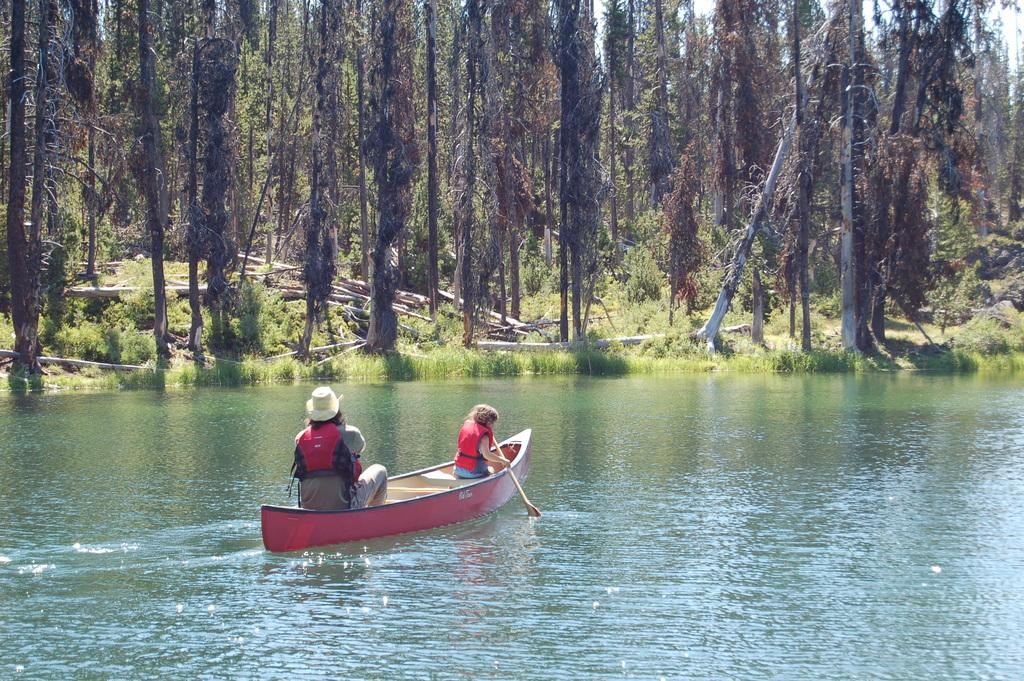Who is present in the image? There is a man and a woman in the image. What are they doing in the image? Both the man and the woman are in a boat. What are they holding in their hands? They are holding ears in their hands. Where is the boat located? The boat is on the water. What can be seen in the background of the image? There are trees in the background of the image. What type of skin condition can be seen on the woman's face in the image? There is no indication of a skin condition on the woman's face in the image. What letter is being held by the man in the image? There is no letter present in the image; they are holding ears. 